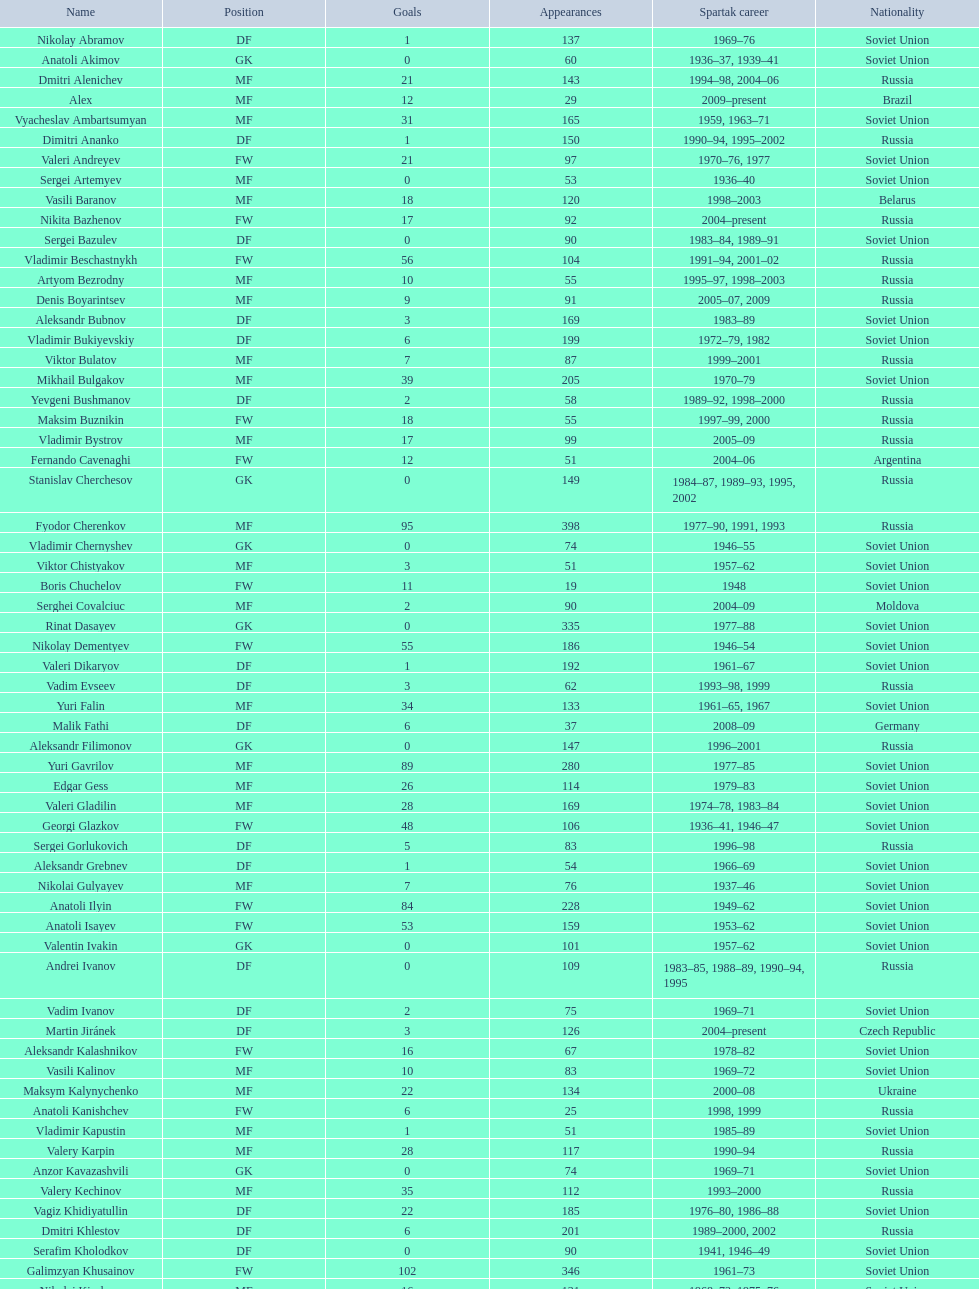Baranov has played from 2004 to the present. what is his nationality? Belarus. Can you parse all the data within this table? {'header': ['Name', 'Position', 'Goals', 'Appearances', 'Spartak career', 'Nationality'], 'rows': [['Nikolay Abramov', 'DF', '1', '137', '1969–76', 'Soviet Union'], ['Anatoli Akimov', 'GK', '0', '60', '1936–37, 1939–41', 'Soviet Union'], ['Dmitri Alenichev', 'MF', '21', '143', '1994–98, 2004–06', 'Russia'], ['Alex', 'MF', '12', '29', '2009–present', 'Brazil'], ['Vyacheslav Ambartsumyan', 'MF', '31', '165', '1959, 1963–71', 'Soviet Union'], ['Dimitri Ananko', 'DF', '1', '150', '1990–94, 1995–2002', 'Russia'], ['Valeri Andreyev', 'FW', '21', '97', '1970–76, 1977', 'Soviet Union'], ['Sergei Artemyev', 'MF', '0', '53', '1936–40', 'Soviet Union'], ['Vasili Baranov', 'MF', '18', '120', '1998–2003', 'Belarus'], ['Nikita Bazhenov', 'FW', '17', '92', '2004–present', 'Russia'], ['Sergei Bazulev', 'DF', '0', '90', '1983–84, 1989–91', 'Soviet Union'], ['Vladimir Beschastnykh', 'FW', '56', '104', '1991–94, 2001–02', 'Russia'], ['Artyom Bezrodny', 'MF', '10', '55', '1995–97, 1998–2003', 'Russia'], ['Denis Boyarintsev', 'MF', '9', '91', '2005–07, 2009', 'Russia'], ['Aleksandr Bubnov', 'DF', '3', '169', '1983–89', 'Soviet Union'], ['Vladimir Bukiyevskiy', 'DF', '6', '199', '1972–79, 1982', 'Soviet Union'], ['Viktor Bulatov', 'MF', '7', '87', '1999–2001', 'Russia'], ['Mikhail Bulgakov', 'MF', '39', '205', '1970–79', 'Soviet Union'], ['Yevgeni Bushmanov', 'DF', '2', '58', '1989–92, 1998–2000', 'Russia'], ['Maksim Buznikin', 'FW', '18', '55', '1997–99, 2000', 'Russia'], ['Vladimir Bystrov', 'MF', '17', '99', '2005–09', 'Russia'], ['Fernando Cavenaghi', 'FW', '12', '51', '2004–06', 'Argentina'], ['Stanislav Cherchesov', 'GK', '0', '149', '1984–87, 1989–93, 1995, 2002', 'Russia'], ['Fyodor Cherenkov', 'MF', '95', '398', '1977–90, 1991, 1993', 'Russia'], ['Vladimir Chernyshev', 'GK', '0', '74', '1946–55', 'Soviet Union'], ['Viktor Chistyakov', 'MF', '3', '51', '1957–62', 'Soviet Union'], ['Boris Chuchelov', 'FW', '11', '19', '1948', 'Soviet Union'], ['Serghei Covalciuc', 'MF', '2', '90', '2004–09', 'Moldova'], ['Rinat Dasayev', 'GK', '0', '335', '1977–88', 'Soviet Union'], ['Nikolay Dementyev', 'FW', '55', '186', '1946–54', 'Soviet Union'], ['Valeri Dikaryov', 'DF', '1', '192', '1961–67', 'Soviet Union'], ['Vadim Evseev', 'DF', '3', '62', '1993–98, 1999', 'Russia'], ['Yuri Falin', 'MF', '34', '133', '1961–65, 1967', 'Soviet Union'], ['Malik Fathi', 'DF', '6', '37', '2008–09', 'Germany'], ['Aleksandr Filimonov', 'GK', '0', '147', '1996–2001', 'Russia'], ['Yuri Gavrilov', 'MF', '89', '280', '1977–85', 'Soviet Union'], ['Edgar Gess', 'MF', '26', '114', '1979–83', 'Soviet Union'], ['Valeri Gladilin', 'MF', '28', '169', '1974–78, 1983–84', 'Soviet Union'], ['Georgi Glazkov', 'FW', '48', '106', '1936–41, 1946–47', 'Soviet Union'], ['Sergei Gorlukovich', 'DF', '5', '83', '1996–98', 'Russia'], ['Aleksandr Grebnev', 'DF', '1', '54', '1966–69', 'Soviet Union'], ['Nikolai Gulyayev', 'MF', '7', '76', '1937–46', 'Soviet Union'], ['Anatoli Ilyin', 'FW', '84', '228', '1949–62', 'Soviet Union'], ['Anatoli Isayev', 'FW', '53', '159', '1953–62', 'Soviet Union'], ['Valentin Ivakin', 'GK', '0', '101', '1957–62', 'Soviet Union'], ['Andrei Ivanov', 'DF', '0', '109', '1983–85, 1988–89, 1990–94, 1995', 'Russia'], ['Vadim Ivanov', 'DF', '2', '75', '1969–71', 'Soviet Union'], ['Martin Jiránek', 'DF', '3', '126', '2004–present', 'Czech Republic'], ['Aleksandr Kalashnikov', 'FW', '16', '67', '1978–82', 'Soviet Union'], ['Vasili Kalinov', 'MF', '10', '83', '1969–72', 'Soviet Union'], ['Maksym Kalynychenko', 'MF', '22', '134', '2000–08', 'Ukraine'], ['Anatoli Kanishchev', 'FW', '6', '25', '1998, 1999', 'Russia'], ['Vladimir Kapustin', 'MF', '1', '51', '1985–89', 'Soviet Union'], ['Valery Karpin', 'MF', '28', '117', '1990–94', 'Russia'], ['Anzor Kavazashvili', 'GK', '0', '74', '1969–71', 'Soviet Union'], ['Valery Kechinov', 'MF', '35', '112', '1993–2000', 'Russia'], ['Vagiz Khidiyatullin', 'DF', '22', '185', '1976–80, 1986–88', 'Soviet Union'], ['Dmitri Khlestov', 'DF', '6', '201', '1989–2000, 2002', 'Russia'], ['Serafim Kholodkov', 'DF', '0', '90', '1941, 1946–49', 'Soviet Union'], ['Galimzyan Khusainov', 'FW', '102', '346', '1961–73', 'Soviet Union'], ['Nikolai Kiselyov', 'MF', '16', '131', '1968–73, 1975–76', 'Soviet Union'], ['Aleksandr Kokorev', 'MF', '4', '90', '1972–80', 'Soviet Union'], ['Ivan Konov', 'FW', '31', '85', '1945–48', 'Soviet Union'], ['Viktor Konovalov', 'MF', '5', '24', '1960–61', 'Soviet Union'], ['Alexey Korneyev', 'DF', '0', '177', '1957–67', 'Soviet Union'], ['Pavel Kornilov', 'FW', '38', '65', '1938–41', 'Soviet Union'], ['Radoslav Kováč', 'MF', '9', '101', '2005–08', 'Czech Republic'], ['Yuri Kovtun', 'DF', '7', '122', '1999–2005', 'Russia'], ['Wojciech Kowalewski', 'GK', '0', '94', '2003–07', 'Poland'], ['Anatoly Krutikov', 'DF', '9', '269', '1959–69', 'Soviet Union'], ['Dmitri Kudryashov', 'MF', '5', '22', '2002', 'Russia'], ['Vasili Kulkov', 'DF', '4', '93', '1986, 1989–91, 1995, 1997', 'Russia'], ['Boris Kuznetsov', 'DF', '0', '90', '1985–88, 1989–90', 'Soviet Union'], ['Yevgeni Kuznetsov', 'MF', '23', '209', '1982–89', 'Soviet Union'], ['Igor Lediakhov', 'MF', '21', '65', '1992–94', 'Russia'], ['Aleksei Leontyev', 'GK', '0', '109', '1940–49', 'Soviet Union'], ['Boris Lobutev', 'FW', '7', '15', '1957–60', 'Soviet Union'], ['Gennady Logofet', 'DF', '27', '349', '1960–75', 'Soviet Union'], ['Evgeny Lovchev', 'MF', '30', '249', '1969–78', 'Soviet Union'], ['Konstantin Malinin', 'DF', '7', '140', '1939–50', 'Soviet Union'], ['Ramiz Mamedov', 'DF', '6', '125', '1991–98', 'Russia'], ['Valeri Masalitin', 'FW', '5', '7', '1994–95', 'Russia'], ['Vladimir Maslachenko', 'GK', '0', '196', '1962–68', 'Soviet Union'], ['Anatoli Maslyonkin', 'DF', '8', '216', '1954–63', 'Soviet Union'], ['Aleksei Melyoshin', 'MF', '5', '68', '1995–2000', 'Russia'], ['Aleksandr Minayev', 'MF', '10', '92', '1972–75', 'Soviet Union'], ['Alexander Mirzoyan', 'DF', '9', '80', '1979–83', 'Soviet Union'], ['Vitali Mirzoyev', 'FW', '4', '58', '1971–74', 'Soviet Union'], ['Viktor Mishin', 'FW', '8', '43', '1956–61', 'Soviet Union'], ['Igor Mitreski', 'DF', '0', '85', '2001–04', 'Macedonia'], ['Gennady Morozov', 'DF', '3', '196', '1980–86, 1989–90', 'Soviet Union'], ['Aleksandr Mostovoi', 'MF', '34', '106', '1986–91', 'Soviet Union'], ['Mozart', 'MF', '7', '68', '2005–08', 'Brazil'], ['Ivan Mozer', 'MF', '30', '96', '1956–61', 'Soviet Union'], ['Mukhsin Mukhamadiev', 'MF', '13', '30', '1994–95', 'Russia'], ['Igor Netto', 'MF', '36', '368', '1949–66', 'Soviet Union'], ['Yuriy Nikiforov', 'DF', '16', '85', '1993–96', 'Russia'], ['Vladimir Nikonov', 'MF', '5', '25', '1979–80, 1982', 'Soviet Union'], ['Sergei Novikov', 'MF', '12', '70', '1978–80, 1985–89', 'Soviet Union'], ['Mikhail Ogonkov', 'DF', '0', '78', '1953–58, 1961', 'Soviet Union'], ['Sergei Olshansky', 'DF', '7', '138', '1969–75', 'Soviet Union'], ['Viktor Onopko', 'DF', '23', '108', '1992–95', 'Russia'], ['Nikolai Osyanin', 'DF', '50', '248', '1966–71, 1974–76', 'Soviet Union'], ['Viktor Papayev', 'MF', '10', '174', '1968–73, 1975–76', 'Soviet Union'], ['Aleksei Paramonov', 'MF', '61', '264', '1947–59', 'Soviet Union'], ['Dmytro Parfenov', 'DF', '15', '125', '1998–2005', 'Ukraine'], ['Nikolai Parshin', 'FW', '36', '106', '1949–58', 'Soviet Union'], ['Viktor Pasulko', 'MF', '16', '75', '1987–89', 'Soviet Union'], ['Aleksandr Pavlenko', 'MF', '11', '110', '2001–07, 2008–09', 'Russia'], ['Vadim Pavlenko', 'FW', '16', '47', '1977–78', 'Soviet Union'], ['Roman Pavlyuchenko', 'FW', '69', '141', '2003–08', 'Russia'], ['Hennadiy Perepadenko', 'MF', '6', '51', '1990–91, 1992', 'Ukraine'], ['Boris Petrov', 'FW', '5', '18', '1962', 'Soviet Union'], ['Vladimir Petrov', 'DF', '5', '174', '1959–71', 'Soviet Union'], ['Andrei Piatnitski', 'MF', '17', '100', '1992–97', 'Russia'], ['Nikolai Pisarev', 'FW', '32', '115', '1992–95, 1998, 2000–01', 'Russia'], ['Aleksandr Piskaryov', 'FW', '33', '117', '1971–75', 'Soviet Union'], ['Mihajlo Pjanović', 'FW', '11', '48', '2003–06', 'Serbia'], ['Stipe Pletikosa', 'GK', '0', '63', '2007–present', 'Croatia'], ['Dmitri Popov', 'DF', '7', '78', '1989–93', 'Russia'], ['Boris Pozdnyakov', 'DF', '3', '145', '1978–84, 1989–91', 'Soviet Union'], ['Vladimir Pribylov', 'FW', '6', '35', '1964–69', 'Soviet Union'], ['Aleksandr Prokhorov', 'GK', '0', '143', '1972–75, 1976–78', 'Soviet Union'], ['Andrei Protasov', 'FW', '10', '32', '1939–41', 'Soviet Union'], ['Dmitri Radchenko', 'FW', '27', '61', '1991–93', 'Russia'], ['Vladimir Redin', 'MF', '12', '90', '1970–74, 1976', 'Soviet Union'], ['Valeri Reyngold', 'FW', '32', '176', '1960–67', 'Soviet Union'], ['Luis Robson', 'FW', '32', '102', '1997–2001', 'Brazil'], ['Sergey Rodionov', 'FW', '124', '303', '1979–90, 1993–95', 'Russia'], ['Clemente Rodríguez', 'DF', '3', '71', '2004–06, 2008–09', 'Argentina'], ['Oleg Romantsev', 'DF', '6', '180', '1976–83', 'Soviet Union'], ['Miroslav Romaschenko', 'MF', '7', '42', '1997–98', 'Belarus'], ['Sergei Rozhkov', 'MF', '8', '143', '1961–65, 1967–69, 1974', 'Soviet Union'], ['Andrei Rudakov', 'FW', '17', '49', '1985–87', 'Soviet Union'], ['Leonid Rumyantsev', 'FW', '8', '26', '1936–40', 'Soviet Union'], ['Mikhail Rusyayev', 'FW', '9', '47', '1981–87, 1992', 'Russia'], ['Konstantin Ryazantsev', 'MF', '5', '114', '1941, 1944–51', 'Soviet Union'], ['Aleksandr Rystsov', 'FW', '16', '100', '1947–54', 'Soviet Union'], ['Sergei Salnikov', 'FW', '64', '201', '1946–49, 1955–60', 'Soviet Union'], ['Aleksandr Samedov', 'MF', '6', '47', '2001–05', 'Russia'], ['Viktor Samokhin', 'MF', '3', '188', '1974–81', 'Soviet Union'], ['Yuri Sedov', 'DF', '2', '176', '1948–55, 1957–59', 'Soviet Union'], ['Anatoli Seglin', 'DF', '0', '83', '1945–52', 'Soviet Union'], ['Viktor Semyonov', 'FW', '49', '104', '1937–47', 'Soviet Union'], ['Yuri Sevidov', 'FW', '54', '146', '1960–65', 'Soviet Union'], ['Igor Shalimov', 'MF', '20', '95', '1986–91', 'Russia'], ['Sergey Shavlo', 'MF', '48', '256', '1977–82, 1984–85', 'Soviet Union'], ['Aleksandr Shirko', 'FW', '40', '128', '1993–2001', 'Russia'], ['Roman Shishkin', 'DF', '1', '54', '2003–08', 'Russia'], ['Valeri Shmarov', 'FW', '54', '143', '1987–91, 1995–96', 'Russia'], ['Sergei Shvetsov', 'DF', '14', '68', '1981–84', 'Soviet Union'], ['Yevgeni Sidorov', 'MF', '18', '191', '1974–81, 1984–85', 'Soviet Union'], ['Dzhemal Silagadze', 'FW', '12', '91', '1968–71, 1973', 'Soviet Union'], ['Nikita Simonyan', 'FW', '135', '215', '1949–59', 'Soviet Union'], ['Boris Smyslov', 'FW', '6', '45', '1945–48', 'Soviet Union'], ['Florin Şoavă', 'DF', '1', '52', '2004–05, 2007–08', 'Romania'], ['Vladimir Sochnov', 'DF', '9', '148', '1981–85, 1989', 'Soviet Union'], ['Aleksei Sokolov', 'FW', '49', '114', '1938–41, 1942, 1944–47', 'Soviet Union'], ['Vasili Sokolov', 'DF', '2', '262', '1938–41, 1942–51', 'Soviet Union'], ['Viktor Sokolov', 'DF', '0', '121', '1936–41, 1942–46', 'Soviet Union'], ['Anatoli Soldatov', 'DF', '1', '113', '1958–65', 'Soviet Union'], ['Aleksandr Sorokin', 'MF', '9', '107', '1977–80', 'Soviet Union'], ['Andrei Starostin', 'MF', '4', '95', '1936–40', 'Soviet Union'], ['Vladimir Stepanov', 'FW', '33', '101', '1936–41, 1942', 'Soviet Union'], ['Andrejs Štolcers', 'MF', '5', '11', '2000', 'Latvia'], ['Martin Stranzl', 'DF', '3', '80', '2006–present', 'Austria'], ['Yuri Susloparov', 'DF', '1', '80', '1986–90', 'Soviet Union'], ['Yuri Syomin', 'MF', '6', '43', '1965–67', 'Soviet Union'], ['Dmitri Sychev', 'FW', '9', '18', '2002', 'Russia'], ['Boris Tatushin', 'FW', '38', '116', '1953–58, 1961', 'Soviet Union'], ['Viktor Terentyev', 'FW', '34', '103', '1948–53', 'Soviet Union'], ['Andrey Tikhonov', 'MF', '68', '191', '1992–2000', 'Russia'], ['Oleg Timakov', 'MF', '19', '182', '1945–54', 'Soviet Union'], ['Nikolai Tishchenko', 'DF', '0', '106', '1951–58', 'Soviet Union'], ['Yegor Titov', 'MF', '86', '324', '1992–2008', 'Russia'], ['Eduard Tsykhmeystruk', 'FW', '5', '35', '2001–02', 'Ukraine'], ['Ilya Tsymbalar', 'MF', '42', '146', '1993–99', 'Russia'], ['Grigori Tuchkov', 'DF', '2', '74', '1937–41, 1942, 1944', 'Soviet Union'], ['Vladas Tučkus', 'GK', '0', '60', '1954–57', 'Soviet Union'], ['Ivan Varlamov', 'DF', '0', '75', '1964–68', 'Soviet Union'], ['Welliton', 'FW', '51', '77', '2007–present', 'Brazil'], ['Vladimir Yanishevskiy', 'FW', '7', '46', '1965–66', 'Soviet Union'], ['Vladimir Yankin', 'MF', '19', '93', '1966–70', 'Soviet Union'], ['Georgi Yartsev', 'FW', '55', '116', '1977–80', 'Soviet Union'], ['Valentin Yemyshev', 'FW', '9', '23', '1948–53', 'Soviet Union'], ['Aleksei Yeryomenko', 'MF', '5', '26', '1986–87', 'Soviet Union'], ['Viktor Yevlentyev', 'MF', '11', '56', '1963–65, 1967–70', 'Soviet Union'], ['Sergei Yuran', 'FW', '5', '26', '1995, 1999', 'Russia'], ['Valeri Zenkov', 'DF', '1', '59', '1971–74', 'Soviet Union']]} 